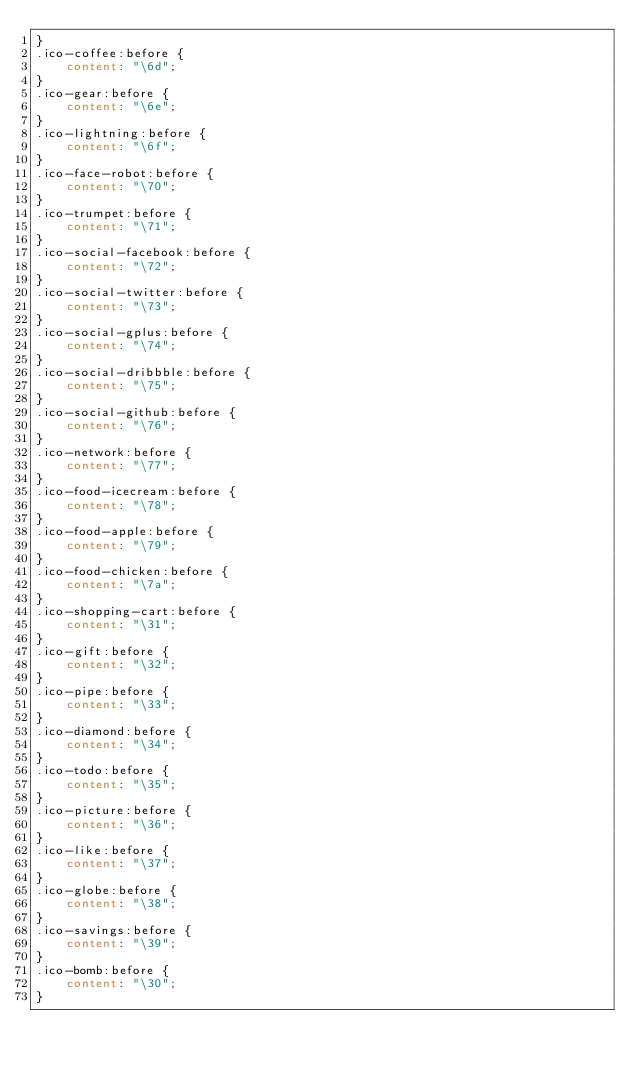<code> <loc_0><loc_0><loc_500><loc_500><_CSS_>}
.ico-coffee:before {
	content: "\6d";
}
.ico-gear:before {
	content: "\6e";
}
.ico-lightning:before {
	content: "\6f";
}
.ico-face-robot:before {
	content: "\70";
}
.ico-trumpet:before {
	content: "\71";
}
.ico-social-facebook:before {
	content: "\72";
}
.ico-social-twitter:before {
	content: "\73";
}
.ico-social-gplus:before {
	content: "\74";
}
.ico-social-dribbble:before {
	content: "\75";
}
.ico-social-github:before {
	content: "\76";
}
.ico-network:before {
	content: "\77";
}
.ico-food-icecream:before {
	content: "\78";
}
.ico-food-apple:before {
	content: "\79";
}
.ico-food-chicken:before {
	content: "\7a";
}
.ico-shopping-cart:before {
	content: "\31";
}
.ico-gift:before {
	content: "\32";
}
.ico-pipe:before {
	content: "\33";
}
.ico-diamond:before {
	content: "\34";
}
.ico-todo:before {
	content: "\35";
}
.ico-picture:before {
	content: "\36";
}
.ico-like:before {
	content: "\37";
}
.ico-globe:before {
	content: "\38";
}
.ico-savings:before {
	content: "\39";
}
.ico-bomb:before {
	content: "\30";
}
</code> 